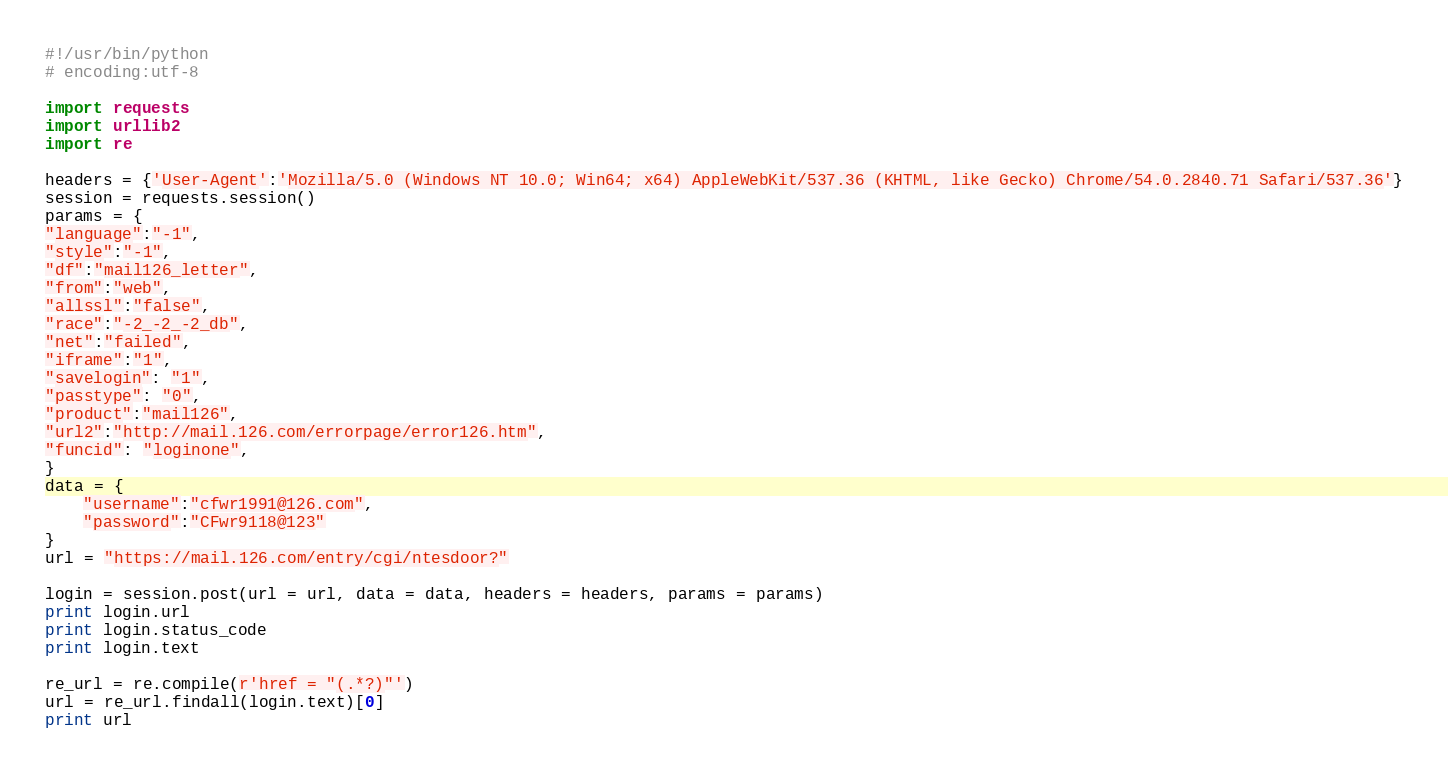Convert code to text. <code><loc_0><loc_0><loc_500><loc_500><_Python_>#!/usr/bin/python
# encoding:utf-8

import requests
import urllib2
import re

headers = {'User-Agent':'Mozilla/5.0 (Windows NT 10.0; Win64; x64) AppleWebKit/537.36 (KHTML, like Gecko) Chrome/54.0.2840.71 Safari/537.36'}
session = requests.session()
params = {
"language":"-1",
"style":"-1",
"df":"mail126_letter",
"from":"web",
"allssl":"false",
"race":"-2_-2_-2_db",
"net":"failed",
"iframe":"1",
"savelogin": "1",
"passtype": "0",
"product":"mail126",
"url2":"http://mail.126.com/errorpage/error126.htm",
"funcid": "loginone",
}
data = {
    "username":"cfwr1991@126.com",
    "password":"CFwr9118@123"
}
url = "https://mail.126.com/entry/cgi/ntesdoor?"

login = session.post(url = url, data = data, headers = headers, params = params)
print login.url
print login.status_code
print login.text

re_url = re.compile(r'href = "(.*?)"')
url = re_url.findall(login.text)[0]
print url
</code> 